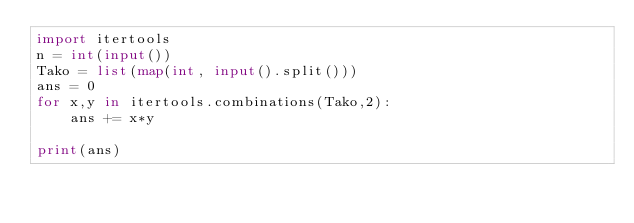<code> <loc_0><loc_0><loc_500><loc_500><_Python_>import itertools
n = int(input())
Tako = list(map(int, input().split()))
ans = 0
for x,y in itertools.combinations(Tako,2):
    ans += x*y

print(ans)</code> 